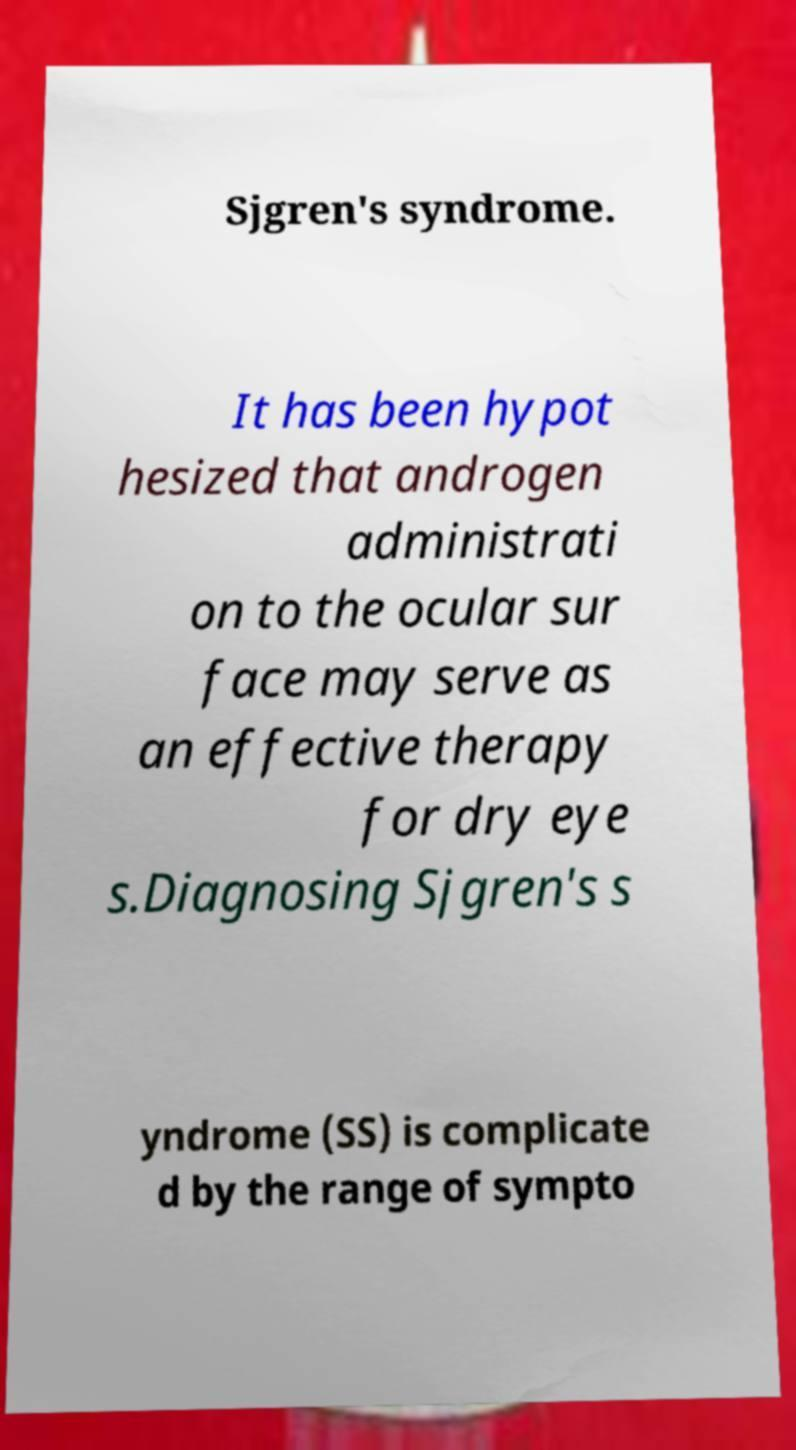Could you extract and type out the text from this image? Sjgren's syndrome. It has been hypot hesized that androgen administrati on to the ocular sur face may serve as an effective therapy for dry eye s.Diagnosing Sjgren's s yndrome (SS) is complicate d by the range of sympto 